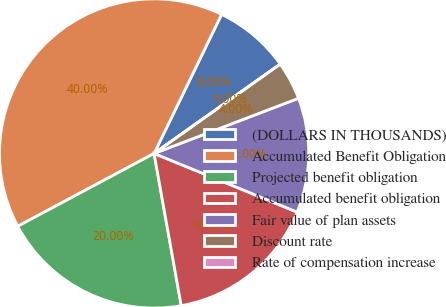<chart> <loc_0><loc_0><loc_500><loc_500><pie_chart><fcel>(DOLLARS IN THOUSANDS)<fcel>Accumulated Benefit Obligation<fcel>Projected benefit obligation<fcel>Accumulated benefit obligation<fcel>Fair value of plan assets<fcel>Discount rate<fcel>Rate of compensation increase<nl><fcel>8.0%<fcel>40.0%<fcel>20.0%<fcel>16.0%<fcel>12.0%<fcel>4.0%<fcel>0.0%<nl></chart> 